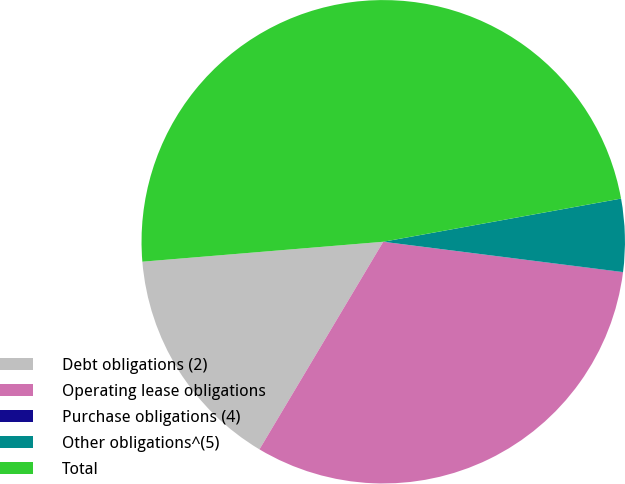Convert chart to OTSL. <chart><loc_0><loc_0><loc_500><loc_500><pie_chart><fcel>Debt obligations (2)<fcel>Operating lease obligations<fcel>Purchase obligations (4)<fcel>Other obligations^(5)<fcel>Total<nl><fcel>15.13%<fcel>31.55%<fcel>0.01%<fcel>4.86%<fcel>48.46%<nl></chart> 